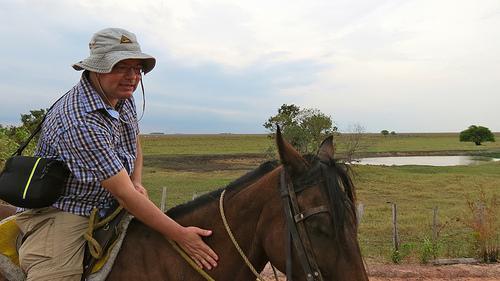How many animals are in the photo?
Give a very brief answer. 1. 